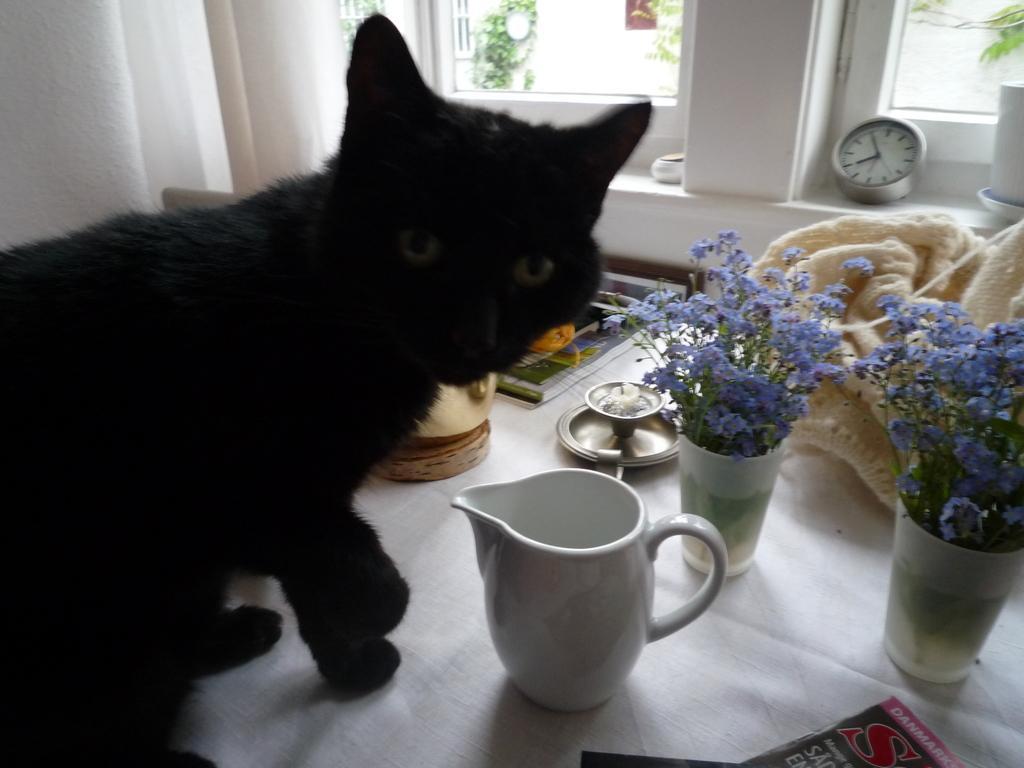Could you give a brief overview of what you see in this image? In the picture we can see a house inside it, we can see a desk, which is white in color on it, we can see a cat which is black in color and besides, we can see a cup which is white in color and some flower vase with some flowers in it which are violet in color and in the background we can see a wall with windows on it we can see a clock and glass to the windows. 